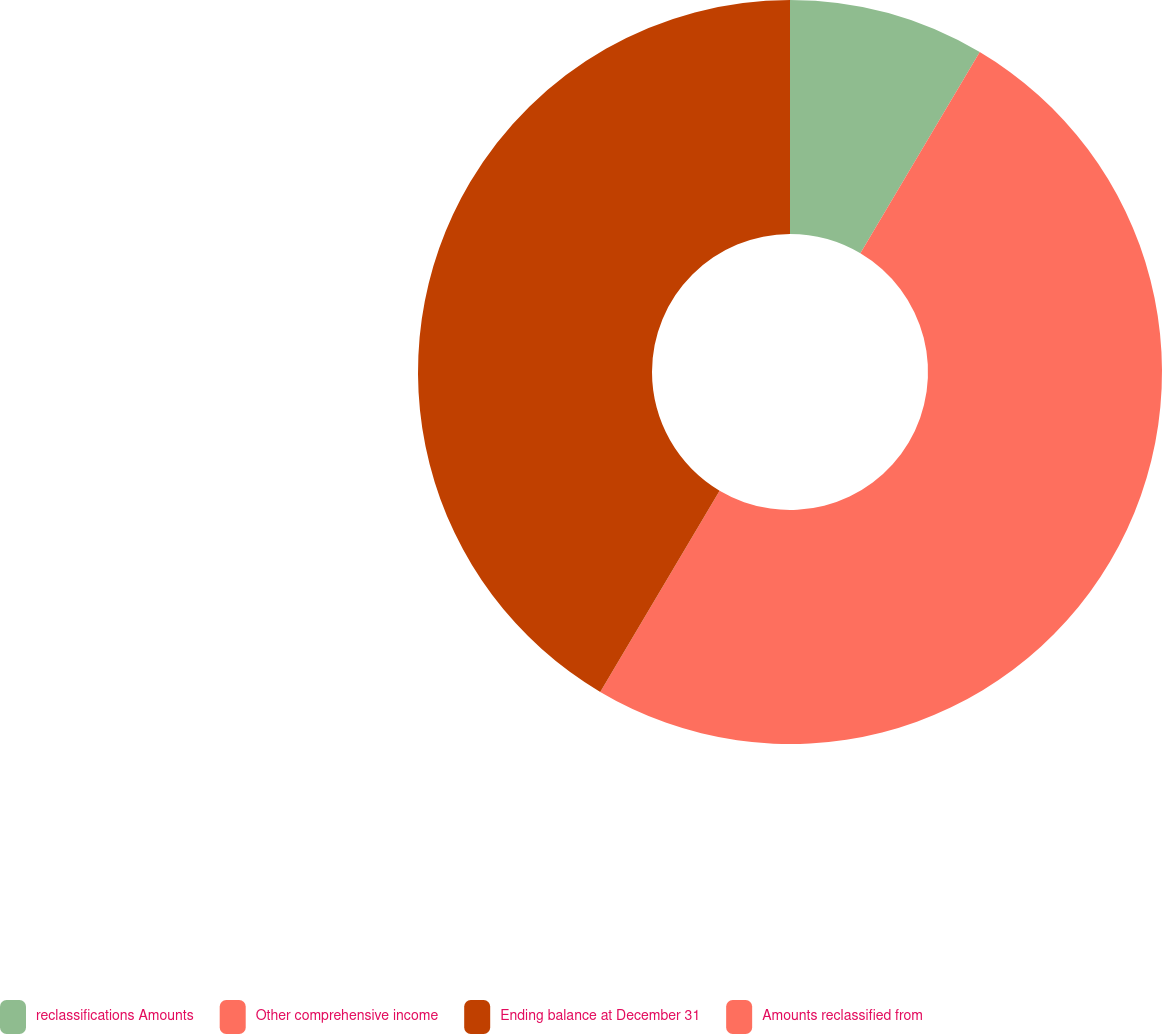<chart> <loc_0><loc_0><loc_500><loc_500><pie_chart><fcel>reclassifications Amounts<fcel>Other comprehensive income<fcel>Ending balance at December 31<fcel>Amounts reclassified from<nl><fcel>8.52%<fcel>50.0%<fcel>41.48%<fcel>0.0%<nl></chart> 